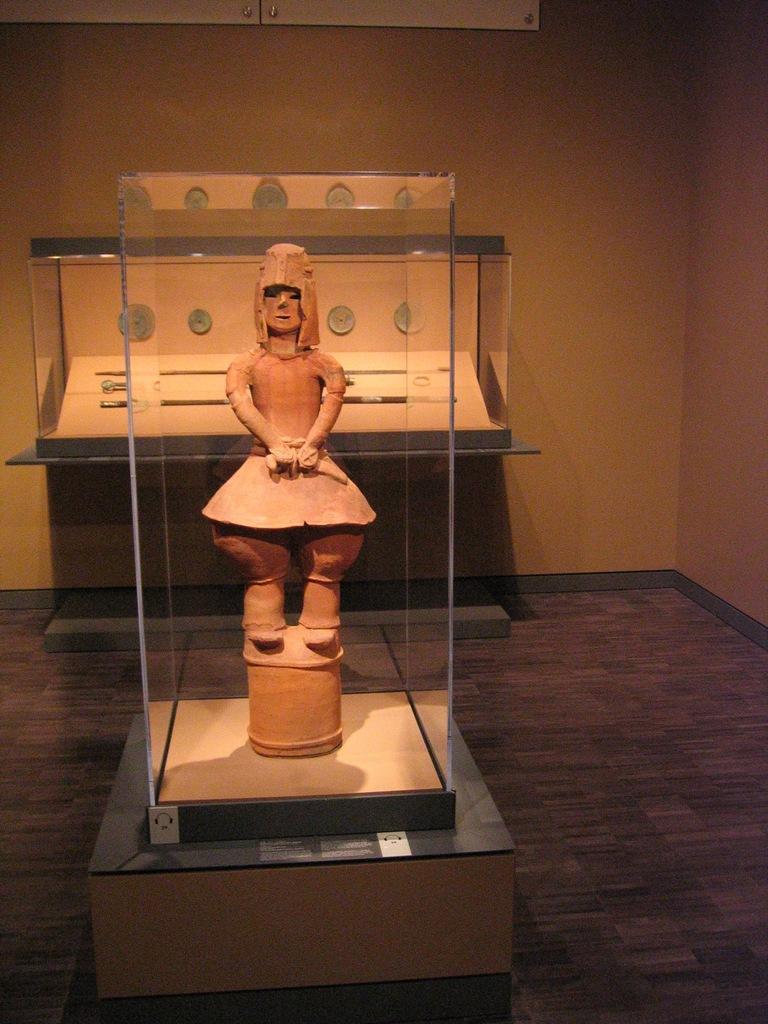Can you describe this image briefly? In this picture we can see a glass in the front, from the glass we can see a statue, in the background there are clocks, we can also see a wall in the background. 